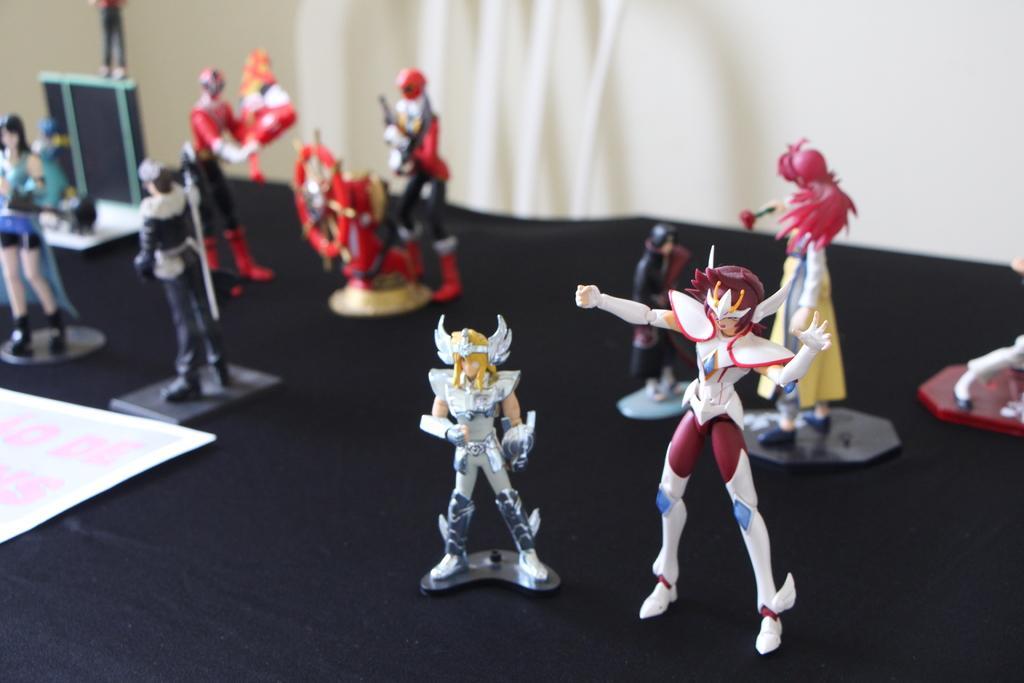In one or two sentences, can you explain what this image depicts? In this picture, we see the animated figurines of the man and the woman. These figures are placed on the table or a black color sheet. These figures are in red, black, white, blue and yellow color. On the left side, we see a chart or a poster in white color with some text written. In the background, we see a wall in white color. This picture is blurred in the background. 